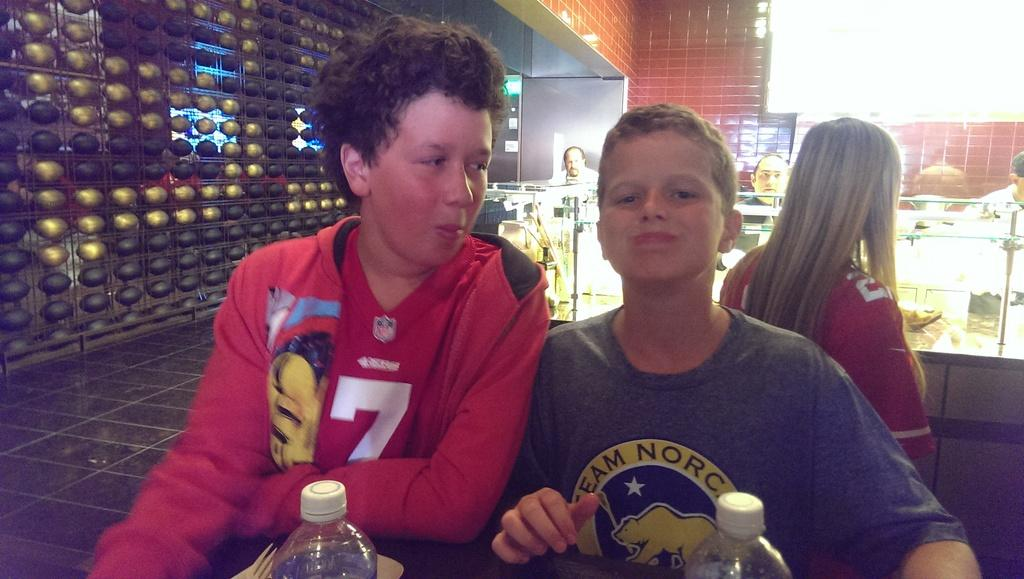What are the people in the image doing? The people in the image are sitting on chairs. What is present in the image besides the people? There is a table in the image. What can be seen on the table? There are water bottles on the table. What type of hen is sitting on the minister's lap in the image? There is no hen or minister present in the image; it only features people sitting on chairs and a table with water bottles. 